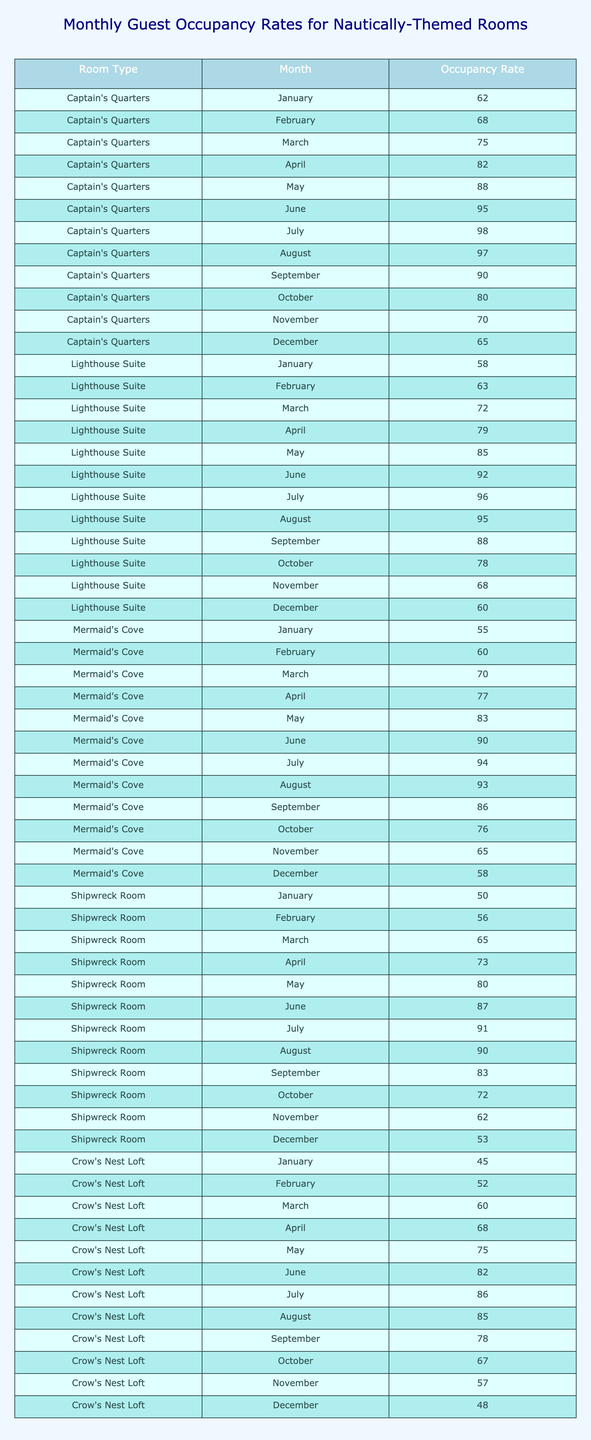What is the occupancy rate for the Captain's Quarters in June? The table shows that the occupancy rate for the Captain's Quarters in June is directly listed under that room/type for that month.
Answer: 95 Which room has the highest occupancy rate in July? By comparing the occupancy rates for all rooms in July, the Captain's Quarters shows 98, which is the highest among all listed.
Answer: Captain's Quarters What is the average occupancy rate for the Lighthouse Suite across all months? To find the average, sum the monthly occupancy rates for the Lighthouse Suite, which are (58 + 63 + 72 + 79 + 85 + 92 + 96 + 95 + 88 + 78 + 68 + 60) = 1004, and divide by the number of months (12). So, 1004/12 = approximately 83.67.
Answer: 83.67 Is there a month where the Shipwreck Room's occupancy rate is higher than the Crow's Nest Loft? Comparing the values for each month, the Shipwreck Room has occupancy rates higher than the Crow's Nest Loft for March, April, May, June, July, August, and September. Therefore, the statement is true.
Answer: Yes What is the total occupancy rate for Mermaid's Cove from January to June? By summing the occupancy rates for Mermaid's Cove from January (55) to June (90): 55 + 60 + 70 + 77 + 83 + 90 = 435.
Answer: 435 Which room has the lowest occupancy rate in December? The table lists the occupancy rates in December: Captain's Quarters (65), Lighthouse Suite (60), Mermaid's Cove (58), Shipwreck Room (53), and Crow's Nest Loft (48). The Crow's Nest Loft has the lowest at 48.
Answer: Crow's Nest Loft What is the difference between the highest and lowest occupancy rates for the Shipwreck Room throughout the year? The highest occupancy rate for the Shipwreck Room is 91 in July and the lowest is 50 in January. The difference is calculated by subtracting the lowest from the highest: 91 - 50 = 41.
Answer: 41 In which month did the Lighthouse Suite see an occupancy rate increase compared to the previous month, right up to July? Analyzing the occupancy rates for the Lighthouse Suite from January to July, it consistently increases each month up to July (58 to 96), so the answer is that all months from January to July saw increases. Therefore, all months leading up to July apply.
Answer: January to July How many rooms have an occupancy rate of at least 70 during April? For April, the occupancy rates are: Captain's Quarters (82), Lighthouse Suite (79), Mermaid's Cove (77), Shipwreck Room (73), and Crow's Nest Loft (68). The rooms that meet the criteria are Captain's Quarters, Lighthouse Suite, Mermaid's Cove, and Shipwreck Room, amounting to four rooms.
Answer: 4 What is the median occupancy rate for all rooms in October? The occupancy rates for October are: Captain's Quarters (80), Lighthouse Suite (78), Mermaid's Cove (76), Shipwreck Room (72), and Crow's Nest Loft (67). The sorted values are 67, 72, 76, 78, 80. The median (the middle value) is 76.
Answer: 76 